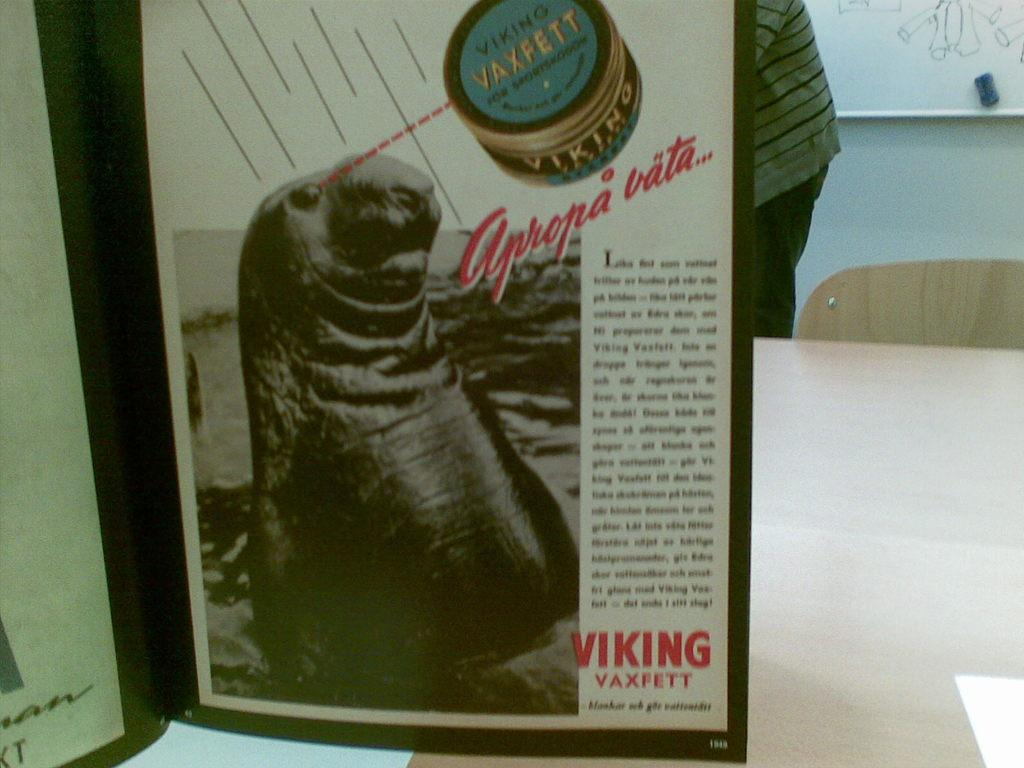<image>
Give a short and clear explanation of the subsequent image. An advertisement for Viking Vaxfett featuring a seal. 